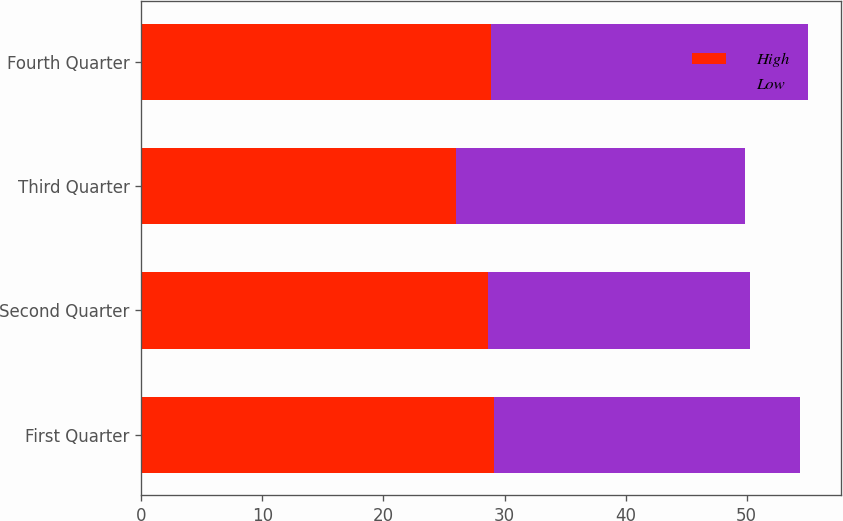Convert chart. <chart><loc_0><loc_0><loc_500><loc_500><stacked_bar_chart><ecel><fcel>First Quarter<fcel>Second Quarter<fcel>Third Quarter<fcel>Fourth Quarter<nl><fcel>High<fcel>29.09<fcel>28.6<fcel>26<fcel>28.85<nl><fcel>Low<fcel>25.3<fcel>21.68<fcel>23.89<fcel>26.18<nl></chart> 